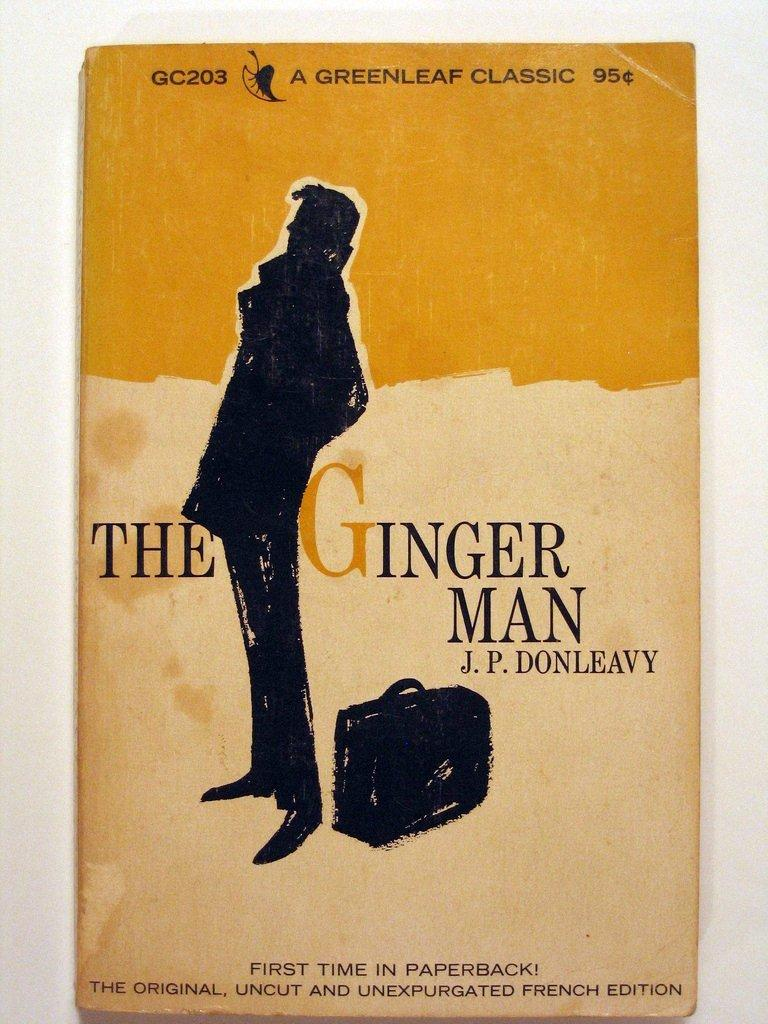What is the main subject of the image? The main subject of the image is a book cover. What is depicted on the book cover? There is a person and a bag depicted on the book cover. What else can be seen on the book cover? There are words present on the book cover. What type of light can be seen illuminating the toys in the image? There are no toys or light sources present in the image; it features a book cover with a person, a bag, and words. 